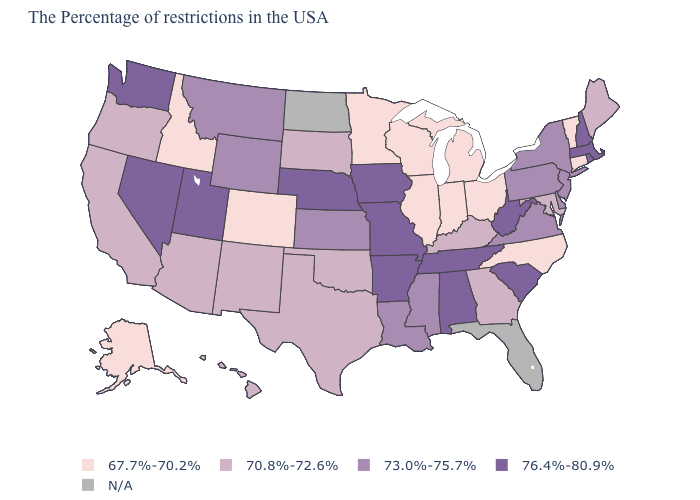Which states have the lowest value in the South?
Keep it brief. North Carolina. Name the states that have a value in the range N/A?
Give a very brief answer. Florida, North Dakota. Among the states that border North Carolina , does South Carolina have the highest value?
Answer briefly. Yes. Name the states that have a value in the range 73.0%-75.7%?
Concise answer only. New York, New Jersey, Delaware, Pennsylvania, Virginia, Mississippi, Louisiana, Kansas, Wyoming, Montana. Is the legend a continuous bar?
Concise answer only. No. Which states hav the highest value in the MidWest?
Quick response, please. Missouri, Iowa, Nebraska. Does Kentucky have the lowest value in the South?
Short answer required. No. Among the states that border Missouri , does Illinois have the highest value?
Short answer required. No. Name the states that have a value in the range N/A?
Write a very short answer. Florida, North Dakota. Which states have the lowest value in the USA?
Quick response, please. Vermont, Connecticut, North Carolina, Ohio, Michigan, Indiana, Wisconsin, Illinois, Minnesota, Colorado, Idaho, Alaska. What is the value of New Jersey?
Answer briefly. 73.0%-75.7%. What is the value of Kentucky?
Write a very short answer. 70.8%-72.6%. What is the highest value in the West ?
Concise answer only. 76.4%-80.9%. What is the value of Iowa?
Give a very brief answer. 76.4%-80.9%. Among the states that border Wisconsin , which have the highest value?
Quick response, please. Iowa. 